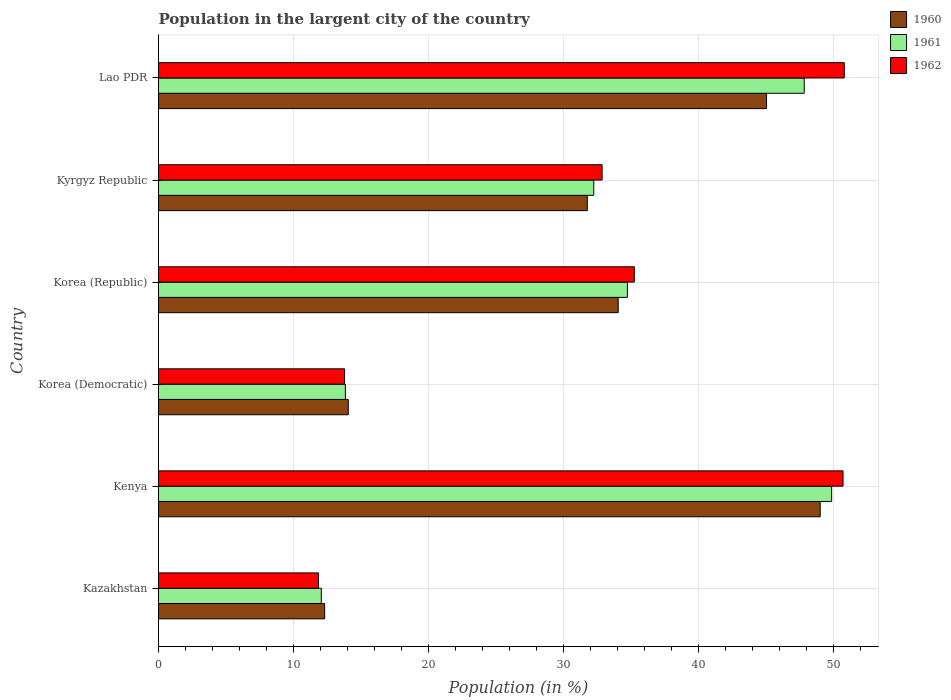How many bars are there on the 4th tick from the top?
Your answer should be compact. 3. What is the label of the 5th group of bars from the top?
Provide a short and direct response. Kenya. What is the percentage of population in the largent city in 1962 in Lao PDR?
Your response must be concise. 50.82. Across all countries, what is the maximum percentage of population in the largent city in 1961?
Give a very brief answer. 49.89. Across all countries, what is the minimum percentage of population in the largent city in 1962?
Offer a very short reply. 11.86. In which country was the percentage of population in the largent city in 1962 maximum?
Keep it short and to the point. Lao PDR. In which country was the percentage of population in the largent city in 1960 minimum?
Provide a short and direct response. Kazakhstan. What is the total percentage of population in the largent city in 1961 in the graph?
Ensure brevity in your answer.  190.66. What is the difference between the percentage of population in the largent city in 1961 in Korea (Republic) and that in Kyrgyz Republic?
Ensure brevity in your answer.  2.49. What is the difference between the percentage of population in the largent city in 1961 in Lao PDR and the percentage of population in the largent city in 1960 in Kenya?
Your answer should be very brief. -1.18. What is the average percentage of population in the largent city in 1961 per country?
Your response must be concise. 31.78. What is the difference between the percentage of population in the largent city in 1962 and percentage of population in the largent city in 1961 in Lao PDR?
Make the answer very short. 2.97. In how many countries, is the percentage of population in the largent city in 1961 greater than 14 %?
Your answer should be compact. 4. What is the ratio of the percentage of population in the largent city in 1961 in Kenya to that in Korea (Republic)?
Offer a very short reply. 1.44. Is the percentage of population in the largent city in 1962 in Kenya less than that in Kyrgyz Republic?
Your answer should be very brief. No. What is the difference between the highest and the second highest percentage of population in the largent city in 1961?
Your answer should be very brief. 2.03. What is the difference between the highest and the lowest percentage of population in the largent city in 1961?
Give a very brief answer. 37.82. In how many countries, is the percentage of population in the largent city in 1960 greater than the average percentage of population in the largent city in 1960 taken over all countries?
Offer a very short reply. 4. Is the sum of the percentage of population in the largent city in 1960 in Kazakhstan and Korea (Republic) greater than the maximum percentage of population in the largent city in 1962 across all countries?
Provide a short and direct response. No. Is it the case that in every country, the sum of the percentage of population in the largent city in 1961 and percentage of population in the largent city in 1962 is greater than the percentage of population in the largent city in 1960?
Offer a very short reply. Yes. How many bars are there?
Keep it short and to the point. 18. Are all the bars in the graph horizontal?
Your answer should be very brief. Yes. How many countries are there in the graph?
Make the answer very short. 6. Are the values on the major ticks of X-axis written in scientific E-notation?
Offer a very short reply. No. Does the graph contain any zero values?
Your response must be concise. No. Where does the legend appear in the graph?
Provide a short and direct response. Top right. How are the legend labels stacked?
Your response must be concise. Vertical. What is the title of the graph?
Your answer should be very brief. Population in the largent city of the country. Does "2004" appear as one of the legend labels in the graph?
Offer a terse response. No. What is the label or title of the X-axis?
Keep it short and to the point. Population (in %). What is the Population (in %) in 1960 in Kazakhstan?
Offer a very short reply. 12.31. What is the Population (in %) of 1961 in Kazakhstan?
Your answer should be compact. 12.06. What is the Population (in %) of 1962 in Kazakhstan?
Offer a very short reply. 11.86. What is the Population (in %) in 1960 in Kenya?
Make the answer very short. 49.04. What is the Population (in %) in 1961 in Kenya?
Make the answer very short. 49.89. What is the Population (in %) of 1962 in Kenya?
Keep it short and to the point. 50.73. What is the Population (in %) in 1960 in Korea (Democratic)?
Your response must be concise. 14.06. What is the Population (in %) in 1961 in Korea (Democratic)?
Offer a terse response. 13.85. What is the Population (in %) of 1962 in Korea (Democratic)?
Keep it short and to the point. 13.79. What is the Population (in %) in 1960 in Korea (Republic)?
Offer a terse response. 34.07. What is the Population (in %) of 1961 in Korea (Republic)?
Provide a succinct answer. 34.75. What is the Population (in %) of 1962 in Korea (Republic)?
Your response must be concise. 35.26. What is the Population (in %) of 1960 in Kyrgyz Republic?
Ensure brevity in your answer.  31.78. What is the Population (in %) of 1961 in Kyrgyz Republic?
Keep it short and to the point. 32.26. What is the Population (in %) in 1962 in Kyrgyz Republic?
Your response must be concise. 32.88. What is the Population (in %) in 1960 in Lao PDR?
Offer a very short reply. 45.06. What is the Population (in %) of 1961 in Lao PDR?
Your response must be concise. 47.86. What is the Population (in %) of 1962 in Lao PDR?
Your answer should be compact. 50.82. Across all countries, what is the maximum Population (in %) in 1960?
Offer a very short reply. 49.04. Across all countries, what is the maximum Population (in %) in 1961?
Offer a very short reply. 49.89. Across all countries, what is the maximum Population (in %) in 1962?
Give a very brief answer. 50.82. Across all countries, what is the minimum Population (in %) in 1960?
Your answer should be very brief. 12.31. Across all countries, what is the minimum Population (in %) in 1961?
Keep it short and to the point. 12.06. Across all countries, what is the minimum Population (in %) in 1962?
Your response must be concise. 11.86. What is the total Population (in %) in 1960 in the graph?
Your answer should be very brief. 186.32. What is the total Population (in %) in 1961 in the graph?
Provide a short and direct response. 190.66. What is the total Population (in %) in 1962 in the graph?
Offer a terse response. 195.34. What is the difference between the Population (in %) of 1960 in Kazakhstan and that in Kenya?
Ensure brevity in your answer.  -36.73. What is the difference between the Population (in %) in 1961 in Kazakhstan and that in Kenya?
Your response must be concise. -37.82. What is the difference between the Population (in %) in 1962 in Kazakhstan and that in Kenya?
Offer a terse response. -38.88. What is the difference between the Population (in %) in 1960 in Kazakhstan and that in Korea (Democratic)?
Offer a very short reply. -1.75. What is the difference between the Population (in %) in 1961 in Kazakhstan and that in Korea (Democratic)?
Your answer should be compact. -1.79. What is the difference between the Population (in %) in 1962 in Kazakhstan and that in Korea (Democratic)?
Make the answer very short. -1.93. What is the difference between the Population (in %) in 1960 in Kazakhstan and that in Korea (Republic)?
Provide a short and direct response. -21.75. What is the difference between the Population (in %) of 1961 in Kazakhstan and that in Korea (Republic)?
Provide a succinct answer. -22.69. What is the difference between the Population (in %) in 1962 in Kazakhstan and that in Korea (Republic)?
Your answer should be very brief. -23.41. What is the difference between the Population (in %) in 1960 in Kazakhstan and that in Kyrgyz Republic?
Ensure brevity in your answer.  -19.46. What is the difference between the Population (in %) in 1961 in Kazakhstan and that in Kyrgyz Republic?
Your answer should be very brief. -20.19. What is the difference between the Population (in %) of 1962 in Kazakhstan and that in Kyrgyz Republic?
Ensure brevity in your answer.  -21.02. What is the difference between the Population (in %) in 1960 in Kazakhstan and that in Lao PDR?
Your answer should be compact. -32.75. What is the difference between the Population (in %) of 1961 in Kazakhstan and that in Lao PDR?
Your response must be concise. -35.79. What is the difference between the Population (in %) in 1962 in Kazakhstan and that in Lao PDR?
Give a very brief answer. -38.97. What is the difference between the Population (in %) of 1960 in Kenya and that in Korea (Democratic)?
Provide a succinct answer. 34.97. What is the difference between the Population (in %) of 1961 in Kenya and that in Korea (Democratic)?
Your answer should be very brief. 36.04. What is the difference between the Population (in %) of 1962 in Kenya and that in Korea (Democratic)?
Offer a very short reply. 36.94. What is the difference between the Population (in %) of 1960 in Kenya and that in Korea (Republic)?
Ensure brevity in your answer.  14.97. What is the difference between the Population (in %) of 1961 in Kenya and that in Korea (Republic)?
Provide a short and direct response. 15.14. What is the difference between the Population (in %) in 1962 in Kenya and that in Korea (Republic)?
Your answer should be compact. 15.47. What is the difference between the Population (in %) in 1960 in Kenya and that in Kyrgyz Republic?
Your answer should be very brief. 17.26. What is the difference between the Population (in %) in 1961 in Kenya and that in Kyrgyz Republic?
Provide a succinct answer. 17.63. What is the difference between the Population (in %) in 1962 in Kenya and that in Kyrgyz Republic?
Offer a very short reply. 17.85. What is the difference between the Population (in %) in 1960 in Kenya and that in Lao PDR?
Your answer should be compact. 3.98. What is the difference between the Population (in %) of 1961 in Kenya and that in Lao PDR?
Ensure brevity in your answer.  2.03. What is the difference between the Population (in %) of 1962 in Kenya and that in Lao PDR?
Keep it short and to the point. -0.09. What is the difference between the Population (in %) in 1960 in Korea (Democratic) and that in Korea (Republic)?
Provide a short and direct response. -20. What is the difference between the Population (in %) of 1961 in Korea (Democratic) and that in Korea (Republic)?
Your answer should be very brief. -20.9. What is the difference between the Population (in %) of 1962 in Korea (Democratic) and that in Korea (Republic)?
Make the answer very short. -21.47. What is the difference between the Population (in %) in 1960 in Korea (Democratic) and that in Kyrgyz Republic?
Your response must be concise. -17.71. What is the difference between the Population (in %) in 1961 in Korea (Democratic) and that in Kyrgyz Republic?
Your answer should be very brief. -18.41. What is the difference between the Population (in %) in 1962 in Korea (Democratic) and that in Kyrgyz Republic?
Provide a succinct answer. -19.09. What is the difference between the Population (in %) of 1960 in Korea (Democratic) and that in Lao PDR?
Offer a terse response. -31. What is the difference between the Population (in %) in 1961 in Korea (Democratic) and that in Lao PDR?
Give a very brief answer. -34.01. What is the difference between the Population (in %) in 1962 in Korea (Democratic) and that in Lao PDR?
Provide a succinct answer. -37.04. What is the difference between the Population (in %) in 1960 in Korea (Republic) and that in Kyrgyz Republic?
Make the answer very short. 2.29. What is the difference between the Population (in %) in 1961 in Korea (Republic) and that in Kyrgyz Republic?
Provide a short and direct response. 2.49. What is the difference between the Population (in %) in 1962 in Korea (Republic) and that in Kyrgyz Republic?
Make the answer very short. 2.38. What is the difference between the Population (in %) of 1960 in Korea (Republic) and that in Lao PDR?
Offer a very short reply. -10.99. What is the difference between the Population (in %) of 1961 in Korea (Republic) and that in Lao PDR?
Your response must be concise. -13.1. What is the difference between the Population (in %) of 1962 in Korea (Republic) and that in Lao PDR?
Make the answer very short. -15.56. What is the difference between the Population (in %) of 1960 in Kyrgyz Republic and that in Lao PDR?
Your response must be concise. -13.28. What is the difference between the Population (in %) of 1961 in Kyrgyz Republic and that in Lao PDR?
Offer a terse response. -15.6. What is the difference between the Population (in %) of 1962 in Kyrgyz Republic and that in Lao PDR?
Provide a short and direct response. -17.95. What is the difference between the Population (in %) in 1960 in Kazakhstan and the Population (in %) in 1961 in Kenya?
Your response must be concise. -37.57. What is the difference between the Population (in %) in 1960 in Kazakhstan and the Population (in %) in 1962 in Kenya?
Offer a terse response. -38.42. What is the difference between the Population (in %) of 1961 in Kazakhstan and the Population (in %) of 1962 in Kenya?
Keep it short and to the point. -38.67. What is the difference between the Population (in %) of 1960 in Kazakhstan and the Population (in %) of 1961 in Korea (Democratic)?
Give a very brief answer. -1.54. What is the difference between the Population (in %) in 1960 in Kazakhstan and the Population (in %) in 1962 in Korea (Democratic)?
Ensure brevity in your answer.  -1.47. What is the difference between the Population (in %) of 1961 in Kazakhstan and the Population (in %) of 1962 in Korea (Democratic)?
Keep it short and to the point. -1.72. What is the difference between the Population (in %) in 1960 in Kazakhstan and the Population (in %) in 1961 in Korea (Republic)?
Your response must be concise. -22.44. What is the difference between the Population (in %) in 1960 in Kazakhstan and the Population (in %) in 1962 in Korea (Republic)?
Your answer should be very brief. -22.95. What is the difference between the Population (in %) in 1961 in Kazakhstan and the Population (in %) in 1962 in Korea (Republic)?
Your answer should be compact. -23.2. What is the difference between the Population (in %) of 1960 in Kazakhstan and the Population (in %) of 1961 in Kyrgyz Republic?
Your response must be concise. -19.94. What is the difference between the Population (in %) of 1960 in Kazakhstan and the Population (in %) of 1962 in Kyrgyz Republic?
Give a very brief answer. -20.56. What is the difference between the Population (in %) in 1961 in Kazakhstan and the Population (in %) in 1962 in Kyrgyz Republic?
Keep it short and to the point. -20.81. What is the difference between the Population (in %) of 1960 in Kazakhstan and the Population (in %) of 1961 in Lao PDR?
Keep it short and to the point. -35.54. What is the difference between the Population (in %) of 1960 in Kazakhstan and the Population (in %) of 1962 in Lao PDR?
Provide a succinct answer. -38.51. What is the difference between the Population (in %) in 1961 in Kazakhstan and the Population (in %) in 1962 in Lao PDR?
Give a very brief answer. -38.76. What is the difference between the Population (in %) in 1960 in Kenya and the Population (in %) in 1961 in Korea (Democratic)?
Ensure brevity in your answer.  35.19. What is the difference between the Population (in %) in 1960 in Kenya and the Population (in %) in 1962 in Korea (Democratic)?
Provide a succinct answer. 35.25. What is the difference between the Population (in %) of 1961 in Kenya and the Population (in %) of 1962 in Korea (Democratic)?
Offer a very short reply. 36.1. What is the difference between the Population (in %) of 1960 in Kenya and the Population (in %) of 1961 in Korea (Republic)?
Make the answer very short. 14.29. What is the difference between the Population (in %) of 1960 in Kenya and the Population (in %) of 1962 in Korea (Republic)?
Provide a succinct answer. 13.78. What is the difference between the Population (in %) of 1961 in Kenya and the Population (in %) of 1962 in Korea (Republic)?
Provide a succinct answer. 14.62. What is the difference between the Population (in %) of 1960 in Kenya and the Population (in %) of 1961 in Kyrgyz Republic?
Ensure brevity in your answer.  16.78. What is the difference between the Population (in %) of 1960 in Kenya and the Population (in %) of 1962 in Kyrgyz Republic?
Your answer should be very brief. 16.16. What is the difference between the Population (in %) in 1961 in Kenya and the Population (in %) in 1962 in Kyrgyz Republic?
Offer a terse response. 17.01. What is the difference between the Population (in %) of 1960 in Kenya and the Population (in %) of 1961 in Lao PDR?
Give a very brief answer. 1.18. What is the difference between the Population (in %) in 1960 in Kenya and the Population (in %) in 1962 in Lao PDR?
Your answer should be very brief. -1.78. What is the difference between the Population (in %) in 1961 in Kenya and the Population (in %) in 1962 in Lao PDR?
Your answer should be compact. -0.94. What is the difference between the Population (in %) in 1960 in Korea (Democratic) and the Population (in %) in 1961 in Korea (Republic)?
Make the answer very short. -20.69. What is the difference between the Population (in %) in 1960 in Korea (Democratic) and the Population (in %) in 1962 in Korea (Republic)?
Your answer should be very brief. -21.2. What is the difference between the Population (in %) in 1961 in Korea (Democratic) and the Population (in %) in 1962 in Korea (Republic)?
Your answer should be compact. -21.41. What is the difference between the Population (in %) of 1960 in Korea (Democratic) and the Population (in %) of 1961 in Kyrgyz Republic?
Your response must be concise. -18.19. What is the difference between the Population (in %) in 1960 in Korea (Democratic) and the Population (in %) in 1962 in Kyrgyz Republic?
Give a very brief answer. -18.81. What is the difference between the Population (in %) in 1961 in Korea (Democratic) and the Population (in %) in 1962 in Kyrgyz Republic?
Ensure brevity in your answer.  -19.03. What is the difference between the Population (in %) of 1960 in Korea (Democratic) and the Population (in %) of 1961 in Lao PDR?
Your answer should be compact. -33.79. What is the difference between the Population (in %) in 1960 in Korea (Democratic) and the Population (in %) in 1962 in Lao PDR?
Offer a terse response. -36.76. What is the difference between the Population (in %) of 1961 in Korea (Democratic) and the Population (in %) of 1962 in Lao PDR?
Offer a terse response. -36.97. What is the difference between the Population (in %) in 1960 in Korea (Republic) and the Population (in %) in 1961 in Kyrgyz Republic?
Provide a short and direct response. 1.81. What is the difference between the Population (in %) of 1960 in Korea (Republic) and the Population (in %) of 1962 in Kyrgyz Republic?
Keep it short and to the point. 1.19. What is the difference between the Population (in %) in 1961 in Korea (Republic) and the Population (in %) in 1962 in Kyrgyz Republic?
Give a very brief answer. 1.87. What is the difference between the Population (in %) of 1960 in Korea (Republic) and the Population (in %) of 1961 in Lao PDR?
Provide a short and direct response. -13.79. What is the difference between the Population (in %) in 1960 in Korea (Republic) and the Population (in %) in 1962 in Lao PDR?
Give a very brief answer. -16.76. What is the difference between the Population (in %) of 1961 in Korea (Republic) and the Population (in %) of 1962 in Lao PDR?
Provide a short and direct response. -16.07. What is the difference between the Population (in %) of 1960 in Kyrgyz Republic and the Population (in %) of 1961 in Lao PDR?
Provide a short and direct response. -16.08. What is the difference between the Population (in %) in 1960 in Kyrgyz Republic and the Population (in %) in 1962 in Lao PDR?
Your answer should be compact. -19.05. What is the difference between the Population (in %) in 1961 in Kyrgyz Republic and the Population (in %) in 1962 in Lao PDR?
Keep it short and to the point. -18.57. What is the average Population (in %) in 1960 per country?
Provide a short and direct response. 31.05. What is the average Population (in %) in 1961 per country?
Ensure brevity in your answer.  31.78. What is the average Population (in %) of 1962 per country?
Provide a short and direct response. 32.56. What is the difference between the Population (in %) of 1960 and Population (in %) of 1961 in Kazakhstan?
Offer a terse response. 0.25. What is the difference between the Population (in %) in 1960 and Population (in %) in 1962 in Kazakhstan?
Your answer should be compact. 0.46. What is the difference between the Population (in %) in 1961 and Population (in %) in 1962 in Kazakhstan?
Ensure brevity in your answer.  0.21. What is the difference between the Population (in %) in 1960 and Population (in %) in 1961 in Kenya?
Your answer should be very brief. -0.85. What is the difference between the Population (in %) in 1960 and Population (in %) in 1962 in Kenya?
Offer a terse response. -1.69. What is the difference between the Population (in %) in 1961 and Population (in %) in 1962 in Kenya?
Make the answer very short. -0.85. What is the difference between the Population (in %) of 1960 and Population (in %) of 1961 in Korea (Democratic)?
Your answer should be compact. 0.21. What is the difference between the Population (in %) in 1960 and Population (in %) in 1962 in Korea (Democratic)?
Your answer should be compact. 0.28. What is the difference between the Population (in %) in 1961 and Population (in %) in 1962 in Korea (Democratic)?
Make the answer very short. 0.06. What is the difference between the Population (in %) in 1960 and Population (in %) in 1961 in Korea (Republic)?
Your answer should be very brief. -0.68. What is the difference between the Population (in %) of 1960 and Population (in %) of 1962 in Korea (Republic)?
Your response must be concise. -1.19. What is the difference between the Population (in %) of 1961 and Population (in %) of 1962 in Korea (Republic)?
Offer a very short reply. -0.51. What is the difference between the Population (in %) in 1960 and Population (in %) in 1961 in Kyrgyz Republic?
Make the answer very short. -0.48. What is the difference between the Population (in %) in 1960 and Population (in %) in 1962 in Kyrgyz Republic?
Keep it short and to the point. -1.1. What is the difference between the Population (in %) in 1961 and Population (in %) in 1962 in Kyrgyz Republic?
Ensure brevity in your answer.  -0.62. What is the difference between the Population (in %) in 1960 and Population (in %) in 1961 in Lao PDR?
Provide a short and direct response. -2.79. What is the difference between the Population (in %) of 1960 and Population (in %) of 1962 in Lao PDR?
Your answer should be very brief. -5.76. What is the difference between the Population (in %) in 1961 and Population (in %) in 1962 in Lao PDR?
Provide a succinct answer. -2.97. What is the ratio of the Population (in %) in 1960 in Kazakhstan to that in Kenya?
Your response must be concise. 0.25. What is the ratio of the Population (in %) of 1961 in Kazakhstan to that in Kenya?
Provide a succinct answer. 0.24. What is the ratio of the Population (in %) of 1962 in Kazakhstan to that in Kenya?
Offer a very short reply. 0.23. What is the ratio of the Population (in %) of 1960 in Kazakhstan to that in Korea (Democratic)?
Provide a short and direct response. 0.88. What is the ratio of the Population (in %) in 1961 in Kazakhstan to that in Korea (Democratic)?
Keep it short and to the point. 0.87. What is the ratio of the Population (in %) in 1962 in Kazakhstan to that in Korea (Democratic)?
Provide a succinct answer. 0.86. What is the ratio of the Population (in %) in 1960 in Kazakhstan to that in Korea (Republic)?
Make the answer very short. 0.36. What is the ratio of the Population (in %) in 1961 in Kazakhstan to that in Korea (Republic)?
Your response must be concise. 0.35. What is the ratio of the Population (in %) in 1962 in Kazakhstan to that in Korea (Republic)?
Make the answer very short. 0.34. What is the ratio of the Population (in %) in 1960 in Kazakhstan to that in Kyrgyz Republic?
Offer a terse response. 0.39. What is the ratio of the Population (in %) of 1961 in Kazakhstan to that in Kyrgyz Republic?
Provide a short and direct response. 0.37. What is the ratio of the Population (in %) in 1962 in Kazakhstan to that in Kyrgyz Republic?
Ensure brevity in your answer.  0.36. What is the ratio of the Population (in %) of 1960 in Kazakhstan to that in Lao PDR?
Provide a short and direct response. 0.27. What is the ratio of the Population (in %) of 1961 in Kazakhstan to that in Lao PDR?
Your answer should be very brief. 0.25. What is the ratio of the Population (in %) in 1962 in Kazakhstan to that in Lao PDR?
Ensure brevity in your answer.  0.23. What is the ratio of the Population (in %) in 1960 in Kenya to that in Korea (Democratic)?
Provide a short and direct response. 3.49. What is the ratio of the Population (in %) in 1961 in Kenya to that in Korea (Democratic)?
Your answer should be compact. 3.6. What is the ratio of the Population (in %) of 1962 in Kenya to that in Korea (Democratic)?
Make the answer very short. 3.68. What is the ratio of the Population (in %) of 1960 in Kenya to that in Korea (Republic)?
Offer a terse response. 1.44. What is the ratio of the Population (in %) in 1961 in Kenya to that in Korea (Republic)?
Keep it short and to the point. 1.44. What is the ratio of the Population (in %) in 1962 in Kenya to that in Korea (Republic)?
Offer a very short reply. 1.44. What is the ratio of the Population (in %) in 1960 in Kenya to that in Kyrgyz Republic?
Your response must be concise. 1.54. What is the ratio of the Population (in %) in 1961 in Kenya to that in Kyrgyz Republic?
Give a very brief answer. 1.55. What is the ratio of the Population (in %) in 1962 in Kenya to that in Kyrgyz Republic?
Your answer should be very brief. 1.54. What is the ratio of the Population (in %) of 1960 in Kenya to that in Lao PDR?
Make the answer very short. 1.09. What is the ratio of the Population (in %) in 1961 in Kenya to that in Lao PDR?
Offer a very short reply. 1.04. What is the ratio of the Population (in %) of 1960 in Korea (Democratic) to that in Korea (Republic)?
Provide a short and direct response. 0.41. What is the ratio of the Population (in %) of 1961 in Korea (Democratic) to that in Korea (Republic)?
Offer a terse response. 0.4. What is the ratio of the Population (in %) in 1962 in Korea (Democratic) to that in Korea (Republic)?
Give a very brief answer. 0.39. What is the ratio of the Population (in %) in 1960 in Korea (Democratic) to that in Kyrgyz Republic?
Offer a very short reply. 0.44. What is the ratio of the Population (in %) of 1961 in Korea (Democratic) to that in Kyrgyz Republic?
Make the answer very short. 0.43. What is the ratio of the Population (in %) in 1962 in Korea (Democratic) to that in Kyrgyz Republic?
Provide a short and direct response. 0.42. What is the ratio of the Population (in %) in 1960 in Korea (Democratic) to that in Lao PDR?
Make the answer very short. 0.31. What is the ratio of the Population (in %) of 1961 in Korea (Democratic) to that in Lao PDR?
Provide a short and direct response. 0.29. What is the ratio of the Population (in %) of 1962 in Korea (Democratic) to that in Lao PDR?
Keep it short and to the point. 0.27. What is the ratio of the Population (in %) in 1960 in Korea (Republic) to that in Kyrgyz Republic?
Your answer should be very brief. 1.07. What is the ratio of the Population (in %) of 1961 in Korea (Republic) to that in Kyrgyz Republic?
Provide a succinct answer. 1.08. What is the ratio of the Population (in %) of 1962 in Korea (Republic) to that in Kyrgyz Republic?
Your answer should be very brief. 1.07. What is the ratio of the Population (in %) of 1960 in Korea (Republic) to that in Lao PDR?
Provide a short and direct response. 0.76. What is the ratio of the Population (in %) of 1961 in Korea (Republic) to that in Lao PDR?
Keep it short and to the point. 0.73. What is the ratio of the Population (in %) of 1962 in Korea (Republic) to that in Lao PDR?
Provide a succinct answer. 0.69. What is the ratio of the Population (in %) in 1960 in Kyrgyz Republic to that in Lao PDR?
Ensure brevity in your answer.  0.71. What is the ratio of the Population (in %) of 1961 in Kyrgyz Republic to that in Lao PDR?
Make the answer very short. 0.67. What is the ratio of the Population (in %) of 1962 in Kyrgyz Republic to that in Lao PDR?
Keep it short and to the point. 0.65. What is the difference between the highest and the second highest Population (in %) of 1960?
Your answer should be compact. 3.98. What is the difference between the highest and the second highest Population (in %) in 1961?
Your answer should be very brief. 2.03. What is the difference between the highest and the second highest Population (in %) of 1962?
Your answer should be very brief. 0.09. What is the difference between the highest and the lowest Population (in %) in 1960?
Provide a succinct answer. 36.73. What is the difference between the highest and the lowest Population (in %) in 1961?
Your response must be concise. 37.82. What is the difference between the highest and the lowest Population (in %) of 1962?
Offer a terse response. 38.97. 